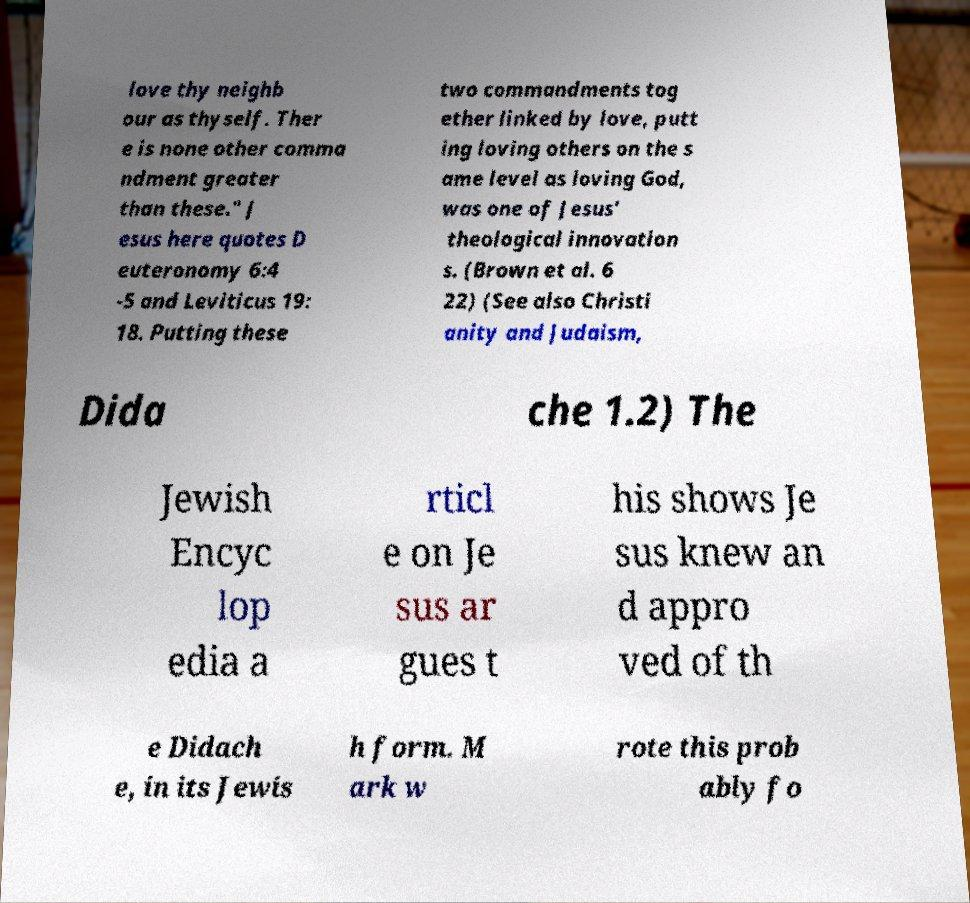Could you assist in decoding the text presented in this image and type it out clearly? love thy neighb our as thyself. Ther e is none other comma ndment greater than these." J esus here quotes D euteronomy 6:4 -5 and Leviticus 19: 18. Putting these two commandments tog ether linked by love, putt ing loving others on the s ame level as loving God, was one of Jesus' theological innovation s. (Brown et al. 6 22) (See also Christi anity and Judaism, Dida che 1.2) The Jewish Encyc lop edia a rticl e on Je sus ar gues t his shows Je sus knew an d appro ved of th e Didach e, in its Jewis h form. M ark w rote this prob ably fo 